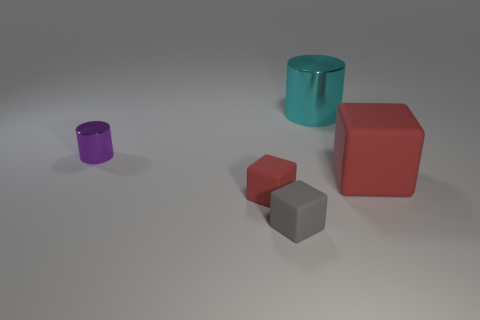What number of other objects are the same shape as the big cyan thing?
Ensure brevity in your answer.  1. There is a matte thing that is behind the small gray thing and on the right side of the small red thing; what is its shape?
Your answer should be compact. Cube. Are there any cyan metal cylinders right of the cyan shiny cylinder?
Provide a short and direct response. No. There is another metallic thing that is the same shape as the cyan shiny object; what is its size?
Offer a very short reply. Small. Is there anything else that has the same size as the purple cylinder?
Give a very brief answer. Yes. Is the small purple metal thing the same shape as the tiny red object?
Make the answer very short. No. There is a red block that is to the left of the big object that is in front of the small metal thing; what size is it?
Provide a succinct answer. Small. There is a big object that is the same shape as the small red rubber object; what is its color?
Ensure brevity in your answer.  Red. What number of tiny cylinders have the same color as the big metal cylinder?
Keep it short and to the point. 0. What is the size of the gray thing?
Offer a very short reply. Small. 